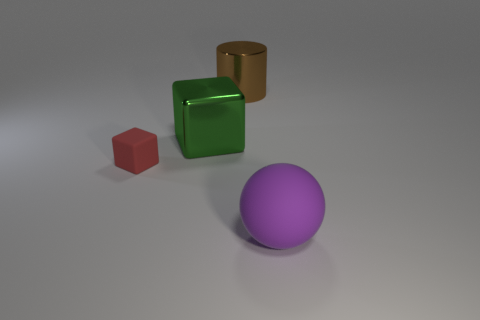Subtract all purple blocks. Subtract all brown balls. How many blocks are left? 2 Add 3 cyan spheres. How many objects exist? 7 Subtract all balls. How many objects are left? 3 Subtract all large brown things. Subtract all small purple things. How many objects are left? 3 Add 3 big rubber spheres. How many big rubber spheres are left? 4 Add 3 green metallic blocks. How many green metallic blocks exist? 4 Subtract 1 red blocks. How many objects are left? 3 